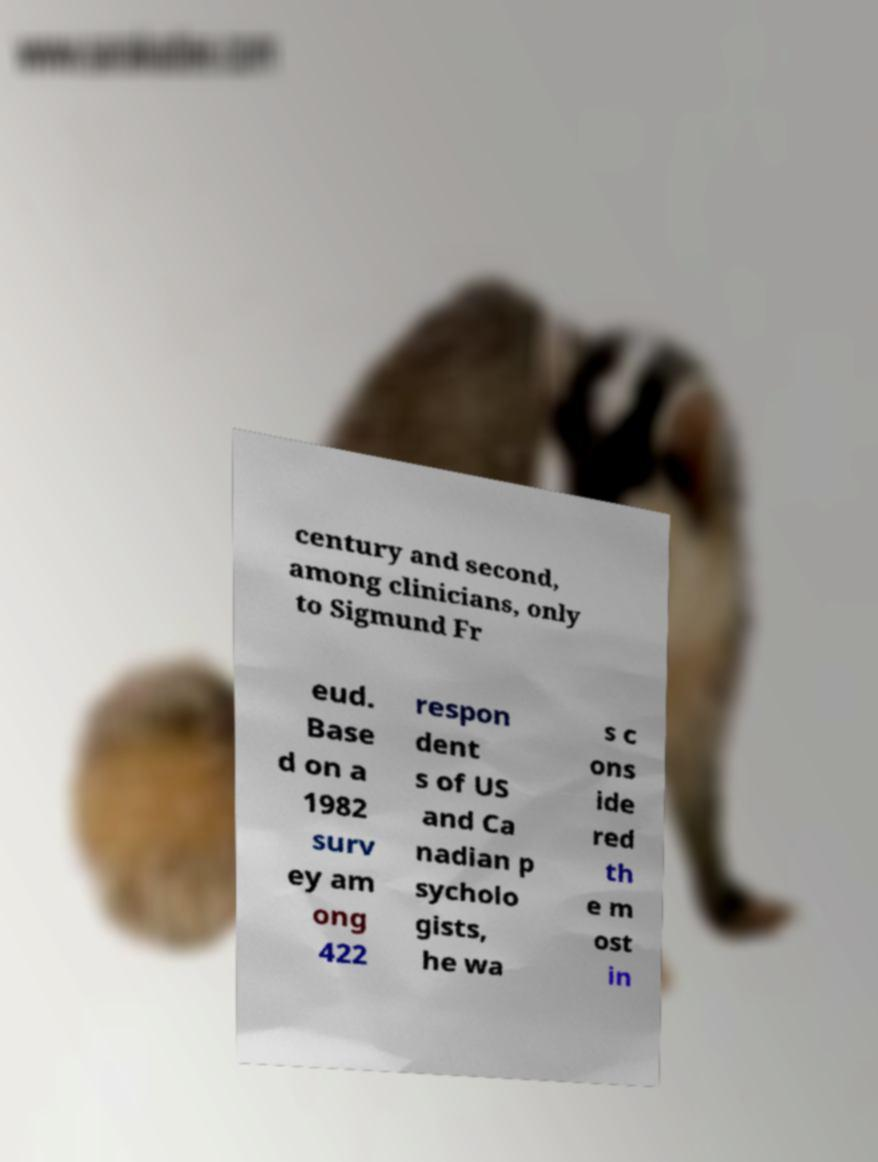Can you accurately transcribe the text from the provided image for me? century and second, among clinicians, only to Sigmund Fr eud. Base d on a 1982 surv ey am ong 422 respon dent s of US and Ca nadian p sycholo gists, he wa s c ons ide red th e m ost in 